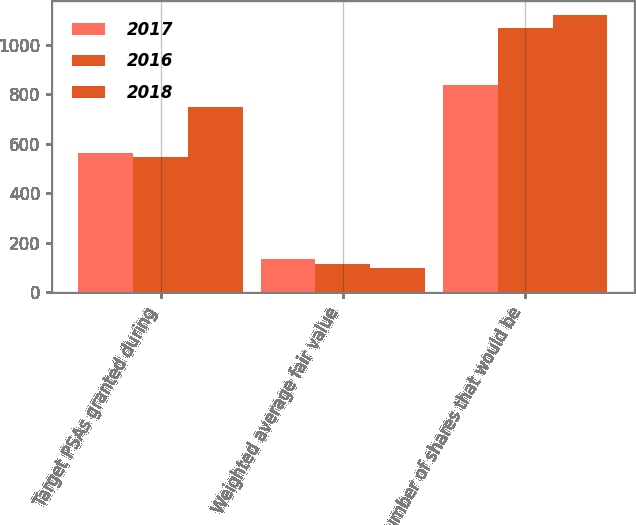Convert chart to OTSL. <chart><loc_0><loc_0><loc_500><loc_500><stacked_bar_chart><ecel><fcel>Target PSAs granted during<fcel>Weighted average fair value<fcel>Number of shares that would be<nl><fcel>2017<fcel>564<fcel>134<fcel>840<nl><fcel>2016<fcel>548<fcel>114<fcel>1068<nl><fcel>2018<fcel>750<fcel>100<fcel>1122<nl></chart> 